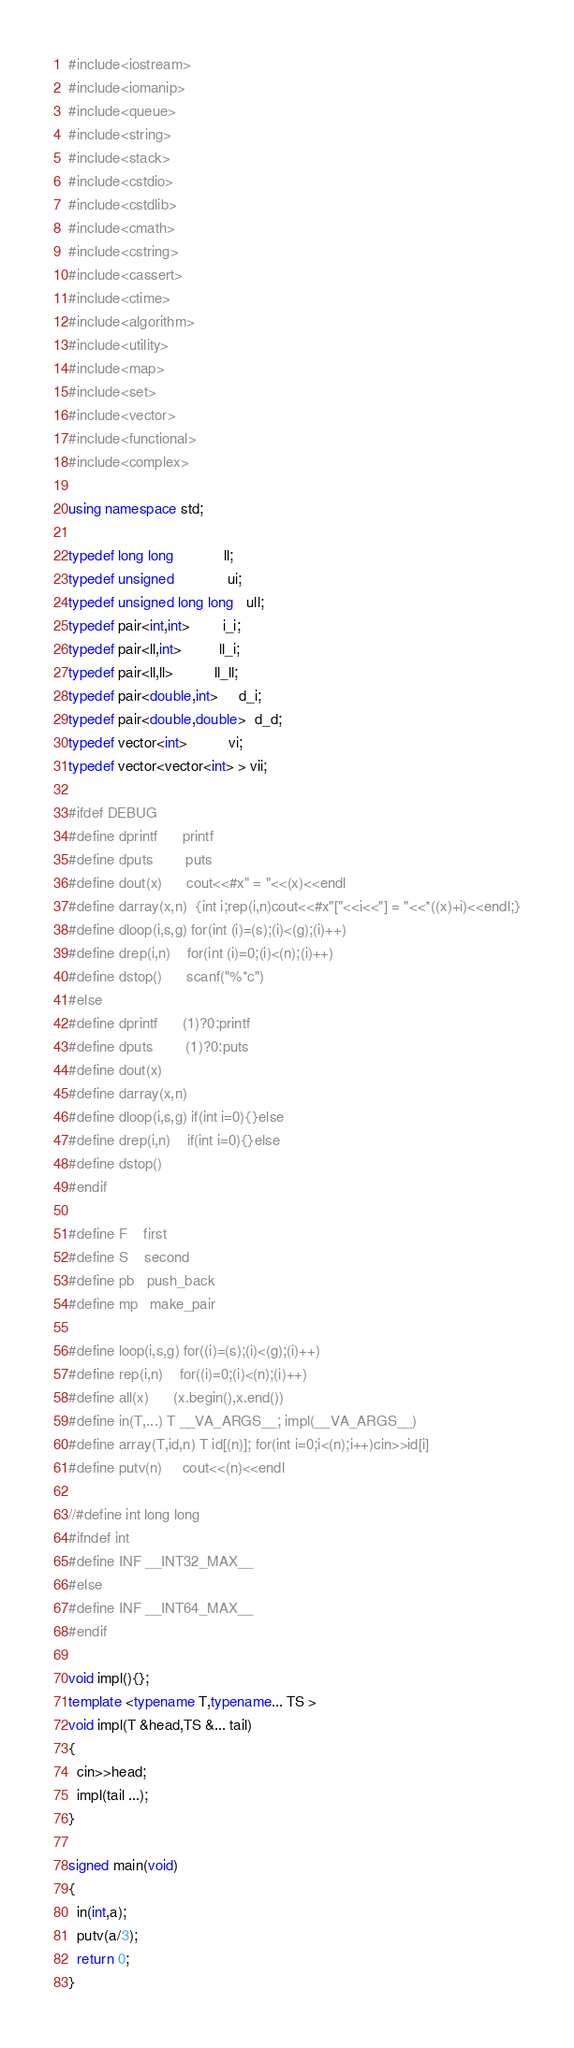Convert code to text. <code><loc_0><loc_0><loc_500><loc_500><_C++_>#include<iostream>
#include<iomanip>
#include<queue>
#include<string>
#include<stack>
#include<cstdio>
#include<cstdlib>
#include<cmath>
#include<cstring>
#include<cassert>
#include<ctime>
#include<algorithm>
#include<utility>
#include<map>
#include<set>
#include<vector>
#include<functional>
#include<complex>

using namespace std;

typedef long long            ll;
typedef unsigned             ui;
typedef unsigned long long   ull;
typedef pair<int,int>        i_i;
typedef pair<ll,int>         ll_i;
typedef pair<ll,ll>          ll_ll;
typedef pair<double,int>     d_i;
typedef pair<double,double>  d_d;
typedef vector<int>          vi;
typedef vector<vector<int> > vii;

#ifdef DEBUG
#define dprintf      printf
#define dputs        puts
#define dout(x)      cout<<#x" = "<<(x)<<endl
#define darray(x,n)  {int i;rep(i,n)cout<<#x"["<<i<<"] = "<<*((x)+i)<<endl;}
#define dloop(i,s,g) for(int (i)=(s);(i)<(g);(i)++)
#define drep(i,n)    for(int (i)=0;(i)<(n);(i)++)
#define dstop()      scanf("%*c")
#else
#define dprintf      (1)?0:printf
#define dputs        (1)?0:puts
#define dout(x)
#define darray(x,n)
#define dloop(i,s,g) if(int i=0){}else
#define drep(i,n)    if(int i=0){}else
#define dstop()
#endif

#define F    first
#define S    second
#define pb   push_back
#define mp   make_pair

#define loop(i,s,g) for((i)=(s);(i)<(g);(i)++)
#define rep(i,n)    for((i)=0;(i)<(n);(i)++)
#define all(x)      (x.begin(),x.end())
#define in(T,...) T __VA_ARGS__; impl(__VA_ARGS__)
#define array(T,id,n) T id[(n)]; for(int i=0;i<(n);i++)cin>>id[i]
#define putv(n)     cout<<(n)<<endl

//#define int long long
#ifndef int
#define INF __INT32_MAX__
#else
#define INF __INT64_MAX__
#endif

void impl(){};
template <typename T,typename... TS >
void impl(T &head,TS &... tail)
{
  cin>>head;
  impl(tail ...);
}

signed main(void)
{
  in(int,a);
  putv(a/3);
  return 0;
}
</code> 